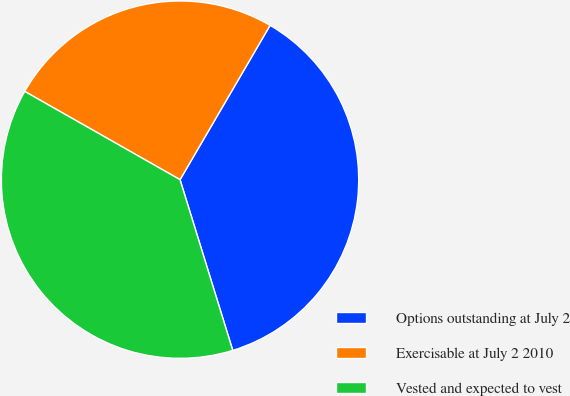Convert chart to OTSL. <chart><loc_0><loc_0><loc_500><loc_500><pie_chart><fcel>Options outstanding at July 2<fcel>Exercisable at July 2 2010<fcel>Vested and expected to vest<nl><fcel>36.83%<fcel>25.18%<fcel>37.99%<nl></chart> 